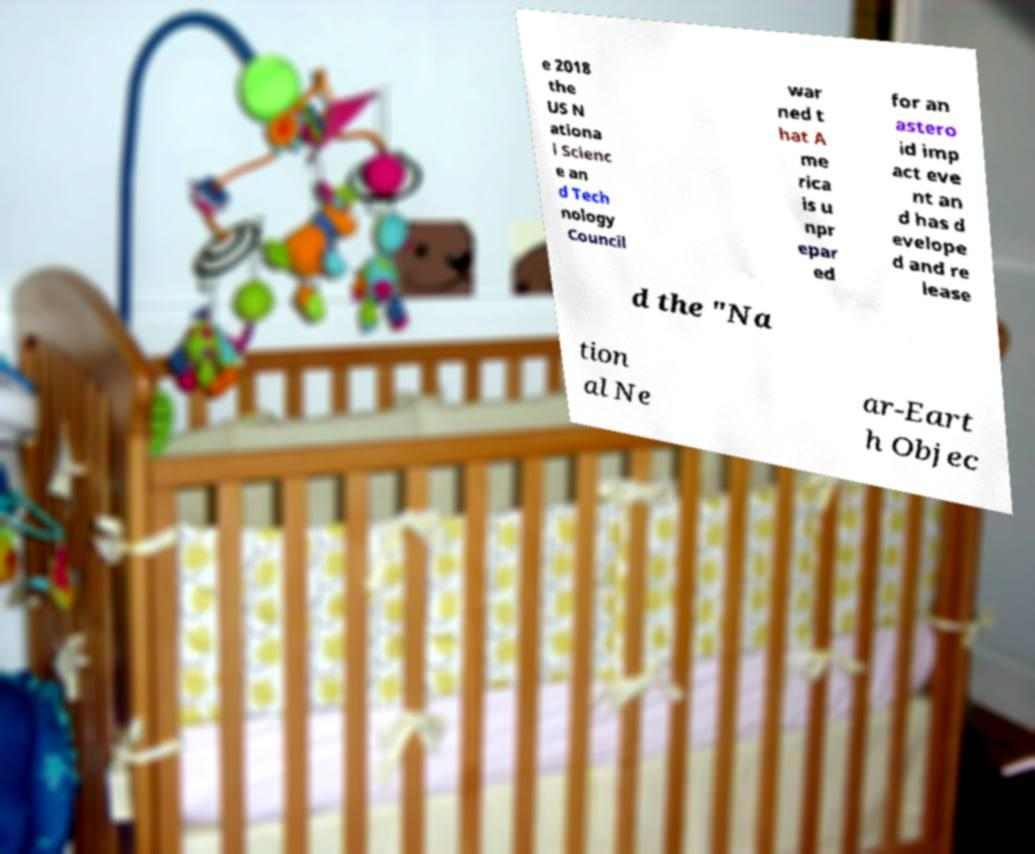There's text embedded in this image that I need extracted. Can you transcribe it verbatim? e 2018 the US N ationa l Scienc e an d Tech nology Council war ned t hat A me rica is u npr epar ed for an astero id imp act eve nt an d has d evelope d and re lease d the "Na tion al Ne ar-Eart h Objec 